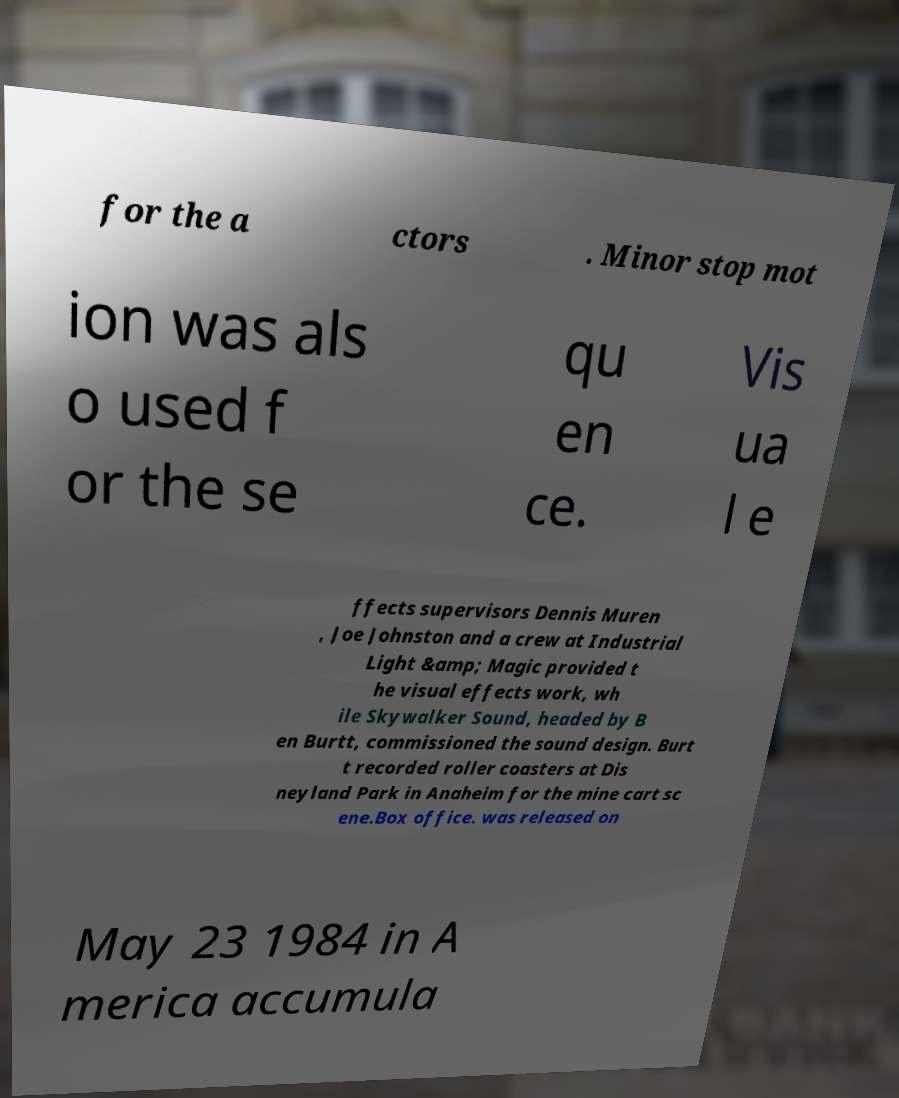Could you assist in decoding the text presented in this image and type it out clearly? for the a ctors . Minor stop mot ion was als o used f or the se qu en ce. Vis ua l e ffects supervisors Dennis Muren , Joe Johnston and a crew at Industrial Light &amp; Magic provided t he visual effects work, wh ile Skywalker Sound, headed by B en Burtt, commissioned the sound design. Burt t recorded roller coasters at Dis neyland Park in Anaheim for the mine cart sc ene.Box office. was released on May 23 1984 in A merica accumula 